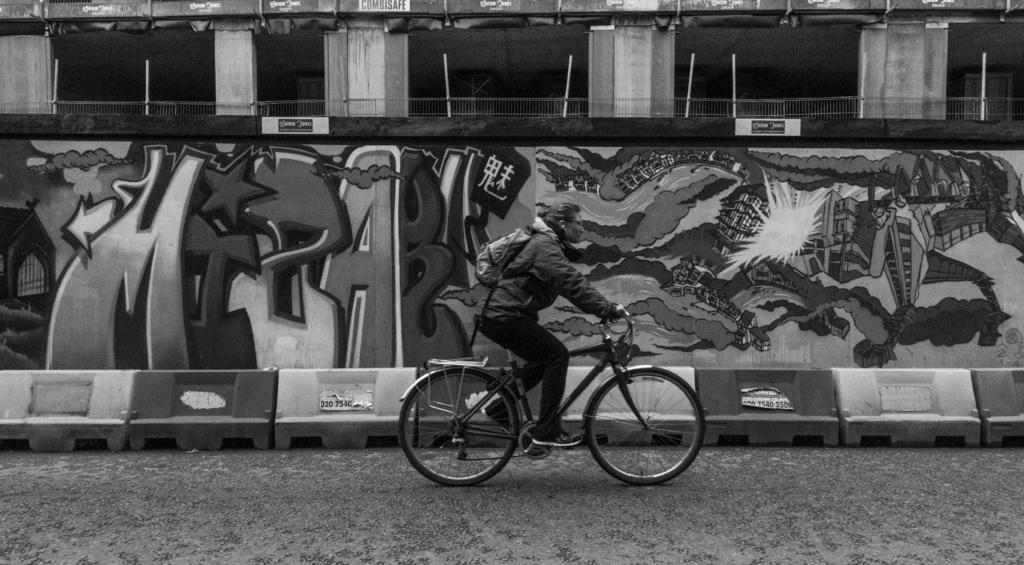What is the main subject of the image? There is a person riding a bicycle in the image. What can be seen in the background of the image? There is a wall in the background of the image. What is on the wall in the image? There is graffiti on the wall. What is at the bottom of the image? There is a road at the bottom of the image. What type of food is the person eating while riding the bicycle in the image? There is no food present in the image; the person is riding a bicycle. How many bananas can be seen in the image? There are no bananas present in the image. 